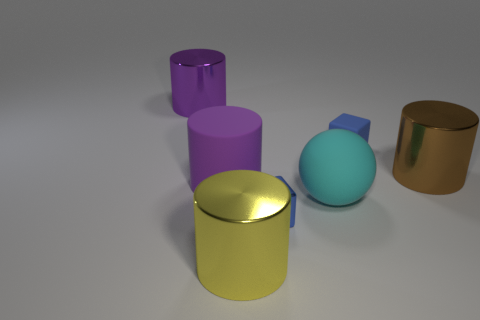What is the material of the other thing that is the same color as the tiny rubber thing?
Offer a very short reply. Metal. There is a matte cube that is the same color as the metallic cube; what is its size?
Make the answer very short. Small. What material is the big cyan ball?
Offer a terse response. Rubber. Is the big cyan object made of the same material as the block that is in front of the big purple matte cylinder?
Ensure brevity in your answer.  No. What is the color of the big object that is behind the small matte block on the right side of the cyan rubber sphere?
Keep it short and to the point. Purple. There is a shiny thing that is behind the purple rubber cylinder and to the right of the big purple metal cylinder; what size is it?
Offer a very short reply. Large. How many other objects are there of the same shape as the big cyan matte object?
Provide a short and direct response. 0. There is a cyan object; is it the same shape as the big object that is behind the brown cylinder?
Your answer should be compact. No. How many big purple cylinders are behind the brown metal cylinder?
Make the answer very short. 1. Does the metal object right of the matte cube have the same shape as the yellow object?
Provide a succinct answer. Yes. 